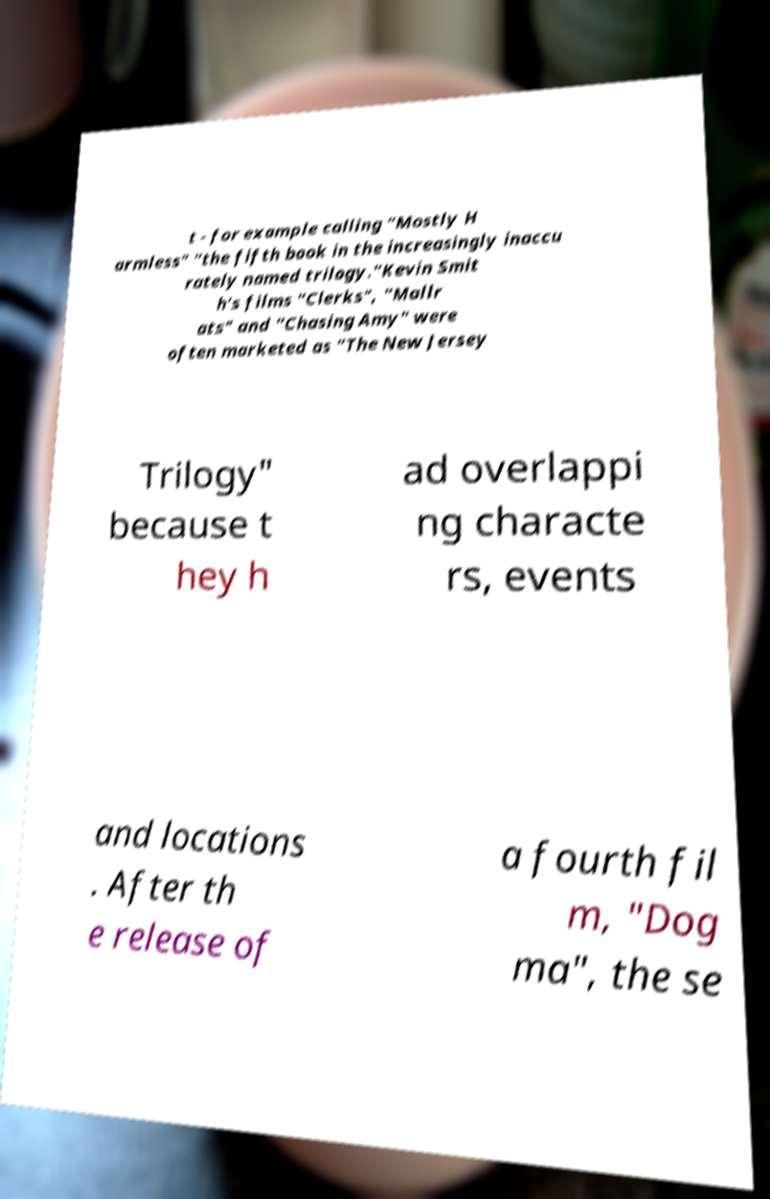Could you extract and type out the text from this image? t - for example calling "Mostly H armless" "the fifth book in the increasingly inaccu rately named trilogy."Kevin Smit h's films "Clerks", "Mallr ats" and "Chasing Amy" were often marketed as "The New Jersey Trilogy" because t hey h ad overlappi ng characte rs, events and locations . After th e release of a fourth fil m, "Dog ma", the se 